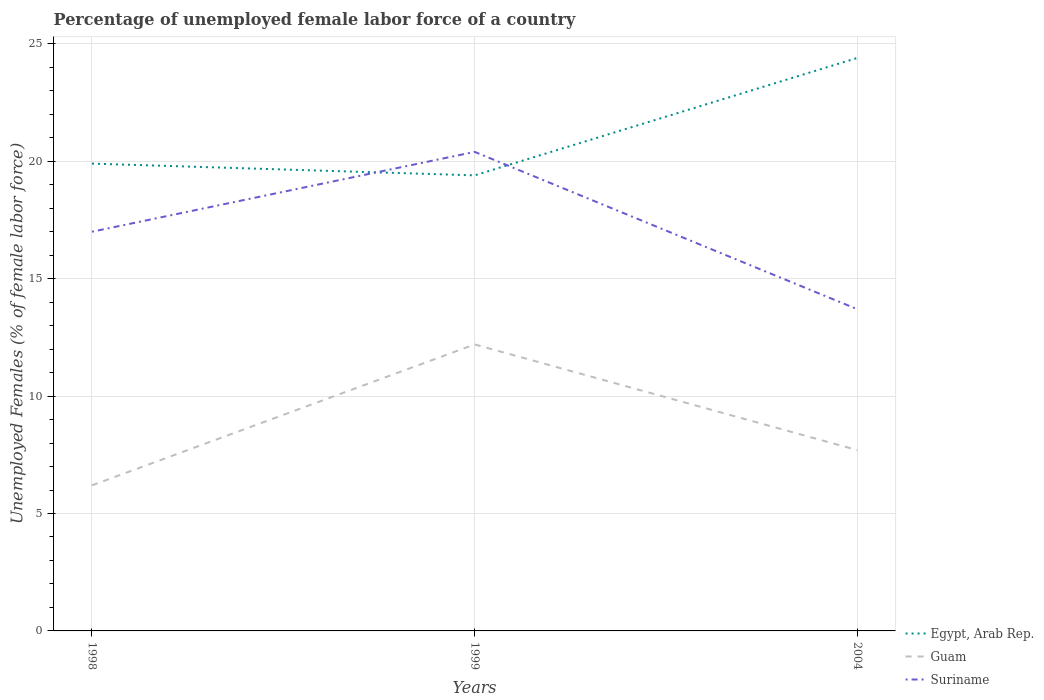How many different coloured lines are there?
Your answer should be very brief. 3. Across all years, what is the maximum percentage of unemployed female labor force in Suriname?
Make the answer very short. 13.7. What is the total percentage of unemployed female labor force in Guam in the graph?
Provide a succinct answer. -6. What is the difference between the highest and the second highest percentage of unemployed female labor force in Suriname?
Offer a very short reply. 6.7. How many years are there in the graph?
Your answer should be very brief. 3. Are the values on the major ticks of Y-axis written in scientific E-notation?
Ensure brevity in your answer.  No. Does the graph contain any zero values?
Your answer should be compact. No. Where does the legend appear in the graph?
Provide a succinct answer. Bottom right. How are the legend labels stacked?
Offer a terse response. Vertical. What is the title of the graph?
Your response must be concise. Percentage of unemployed female labor force of a country. What is the label or title of the Y-axis?
Keep it short and to the point. Unemployed Females (% of female labor force). What is the Unemployed Females (% of female labor force) of Egypt, Arab Rep. in 1998?
Offer a terse response. 19.9. What is the Unemployed Females (% of female labor force) of Guam in 1998?
Your answer should be compact. 6.2. What is the Unemployed Females (% of female labor force) of Egypt, Arab Rep. in 1999?
Give a very brief answer. 19.4. What is the Unemployed Females (% of female labor force) of Guam in 1999?
Make the answer very short. 12.2. What is the Unemployed Females (% of female labor force) of Suriname in 1999?
Keep it short and to the point. 20.4. What is the Unemployed Females (% of female labor force) in Egypt, Arab Rep. in 2004?
Offer a very short reply. 24.4. What is the Unemployed Females (% of female labor force) in Guam in 2004?
Your answer should be compact. 7.7. What is the Unemployed Females (% of female labor force) in Suriname in 2004?
Provide a short and direct response. 13.7. Across all years, what is the maximum Unemployed Females (% of female labor force) of Egypt, Arab Rep.?
Give a very brief answer. 24.4. Across all years, what is the maximum Unemployed Females (% of female labor force) in Guam?
Your answer should be very brief. 12.2. Across all years, what is the maximum Unemployed Females (% of female labor force) of Suriname?
Keep it short and to the point. 20.4. Across all years, what is the minimum Unemployed Females (% of female labor force) in Egypt, Arab Rep.?
Offer a very short reply. 19.4. Across all years, what is the minimum Unemployed Females (% of female labor force) of Guam?
Keep it short and to the point. 6.2. Across all years, what is the minimum Unemployed Females (% of female labor force) in Suriname?
Provide a succinct answer. 13.7. What is the total Unemployed Females (% of female labor force) of Egypt, Arab Rep. in the graph?
Offer a very short reply. 63.7. What is the total Unemployed Females (% of female labor force) in Guam in the graph?
Ensure brevity in your answer.  26.1. What is the total Unemployed Females (% of female labor force) in Suriname in the graph?
Keep it short and to the point. 51.1. What is the difference between the Unemployed Females (% of female labor force) in Egypt, Arab Rep. in 1998 and that in 1999?
Offer a terse response. 0.5. What is the difference between the Unemployed Females (% of female labor force) in Suriname in 1998 and that in 1999?
Provide a short and direct response. -3.4. What is the difference between the Unemployed Females (% of female labor force) of Egypt, Arab Rep. in 1998 and that in 2004?
Offer a very short reply. -4.5. What is the difference between the Unemployed Females (% of female labor force) of Guam in 1998 and that in 2004?
Provide a succinct answer. -1.5. What is the difference between the Unemployed Females (% of female labor force) in Guam in 1999 and that in 2004?
Ensure brevity in your answer.  4.5. What is the difference between the Unemployed Females (% of female labor force) of Egypt, Arab Rep. in 1998 and the Unemployed Females (% of female labor force) of Guam in 1999?
Offer a very short reply. 7.7. What is the difference between the Unemployed Females (% of female labor force) of Egypt, Arab Rep. in 1998 and the Unemployed Females (% of female labor force) of Suriname in 2004?
Offer a terse response. 6.2. What is the difference between the Unemployed Females (% of female labor force) in Guam in 1998 and the Unemployed Females (% of female labor force) in Suriname in 2004?
Your response must be concise. -7.5. What is the difference between the Unemployed Females (% of female labor force) of Egypt, Arab Rep. in 1999 and the Unemployed Females (% of female labor force) of Guam in 2004?
Your response must be concise. 11.7. What is the difference between the Unemployed Females (% of female labor force) of Egypt, Arab Rep. in 1999 and the Unemployed Females (% of female labor force) of Suriname in 2004?
Provide a short and direct response. 5.7. What is the difference between the Unemployed Females (% of female labor force) in Guam in 1999 and the Unemployed Females (% of female labor force) in Suriname in 2004?
Ensure brevity in your answer.  -1.5. What is the average Unemployed Females (% of female labor force) in Egypt, Arab Rep. per year?
Ensure brevity in your answer.  21.23. What is the average Unemployed Females (% of female labor force) of Suriname per year?
Give a very brief answer. 17.03. In the year 1998, what is the difference between the Unemployed Females (% of female labor force) of Egypt, Arab Rep. and Unemployed Females (% of female labor force) of Suriname?
Your answer should be compact. 2.9. In the year 1998, what is the difference between the Unemployed Females (% of female labor force) in Guam and Unemployed Females (% of female labor force) in Suriname?
Your answer should be very brief. -10.8. In the year 1999, what is the difference between the Unemployed Females (% of female labor force) in Egypt, Arab Rep. and Unemployed Females (% of female labor force) in Suriname?
Provide a succinct answer. -1. In the year 1999, what is the difference between the Unemployed Females (% of female labor force) in Guam and Unemployed Females (% of female labor force) in Suriname?
Your response must be concise. -8.2. In the year 2004, what is the difference between the Unemployed Females (% of female labor force) of Guam and Unemployed Females (% of female labor force) of Suriname?
Provide a succinct answer. -6. What is the ratio of the Unemployed Females (% of female labor force) of Egypt, Arab Rep. in 1998 to that in 1999?
Your response must be concise. 1.03. What is the ratio of the Unemployed Females (% of female labor force) in Guam in 1998 to that in 1999?
Offer a terse response. 0.51. What is the ratio of the Unemployed Females (% of female labor force) of Egypt, Arab Rep. in 1998 to that in 2004?
Provide a succinct answer. 0.82. What is the ratio of the Unemployed Females (% of female labor force) of Guam in 1998 to that in 2004?
Keep it short and to the point. 0.81. What is the ratio of the Unemployed Females (% of female labor force) of Suriname in 1998 to that in 2004?
Ensure brevity in your answer.  1.24. What is the ratio of the Unemployed Females (% of female labor force) in Egypt, Arab Rep. in 1999 to that in 2004?
Your response must be concise. 0.8. What is the ratio of the Unemployed Females (% of female labor force) in Guam in 1999 to that in 2004?
Make the answer very short. 1.58. What is the ratio of the Unemployed Females (% of female labor force) of Suriname in 1999 to that in 2004?
Provide a short and direct response. 1.49. What is the difference between the highest and the second highest Unemployed Females (% of female labor force) of Egypt, Arab Rep.?
Your answer should be compact. 4.5. What is the difference between the highest and the second highest Unemployed Females (% of female labor force) in Guam?
Make the answer very short. 4.5. What is the difference between the highest and the lowest Unemployed Females (% of female labor force) of Guam?
Provide a short and direct response. 6. 